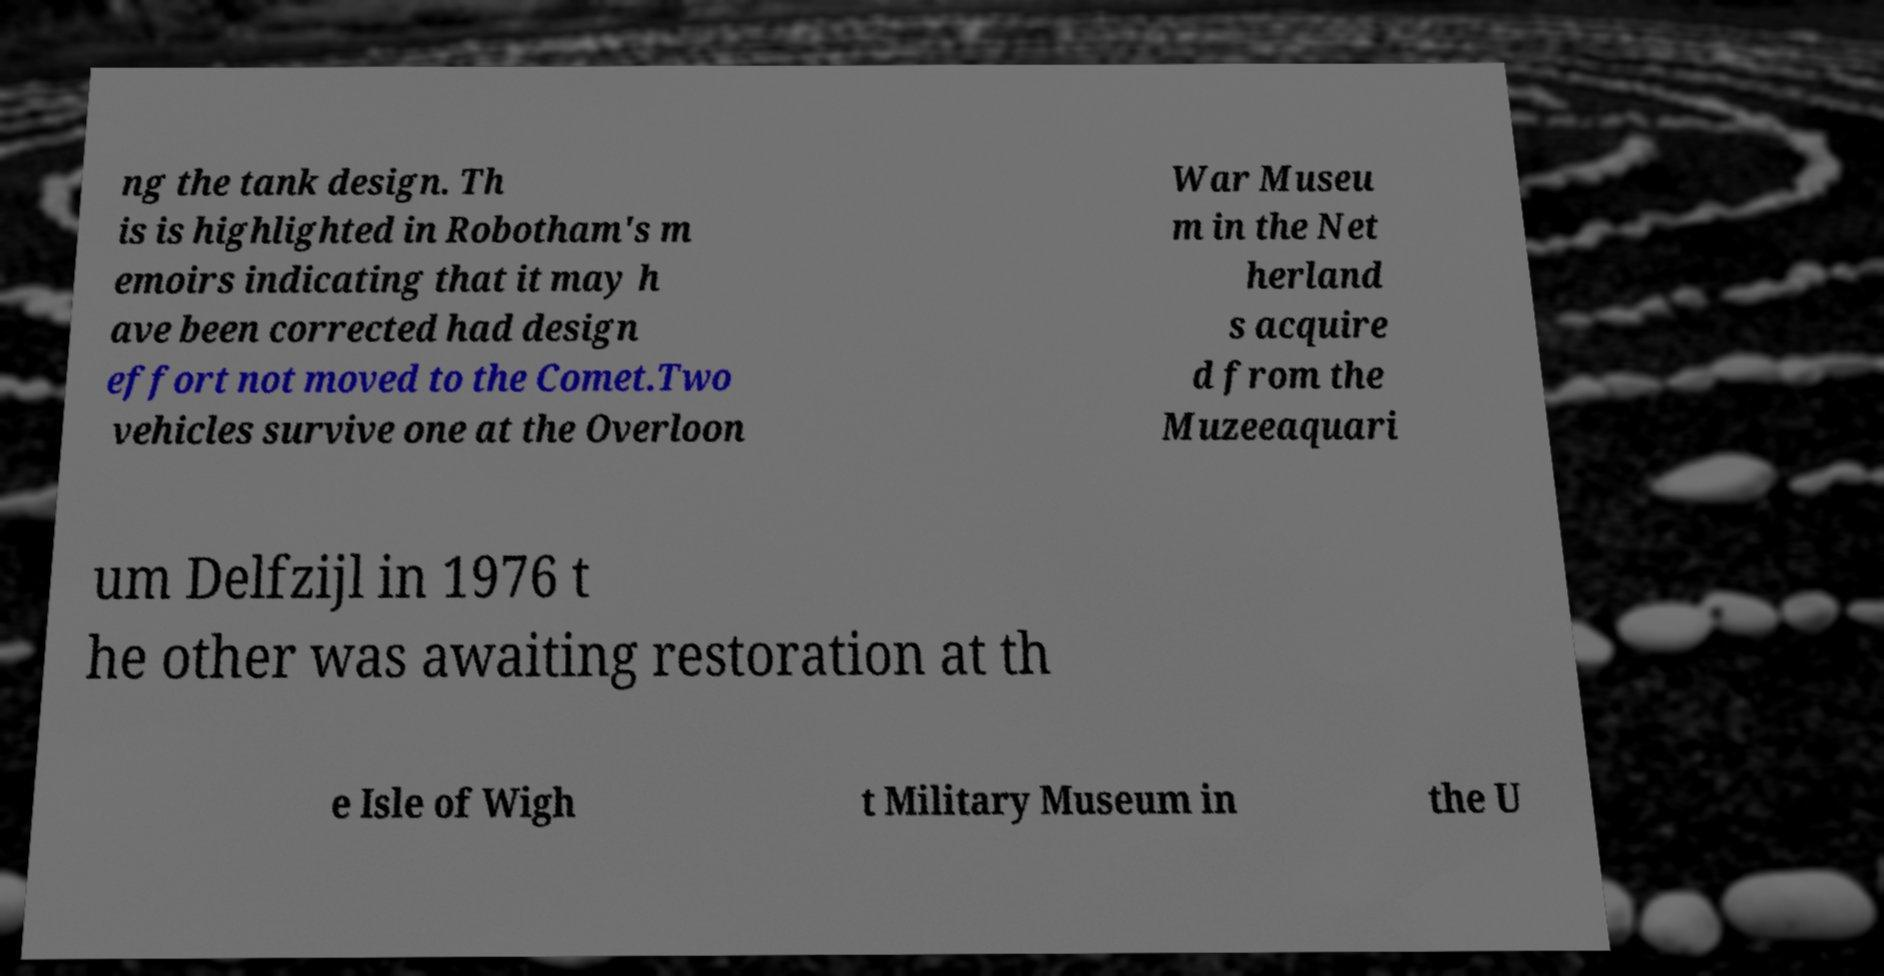Could you assist in decoding the text presented in this image and type it out clearly? ng the tank design. Th is is highlighted in Robotham's m emoirs indicating that it may h ave been corrected had design effort not moved to the Comet.Two vehicles survive one at the Overloon War Museu m in the Net herland s acquire d from the Muzeeaquari um Delfzijl in 1976 t he other was awaiting restoration at th e Isle of Wigh t Military Museum in the U 